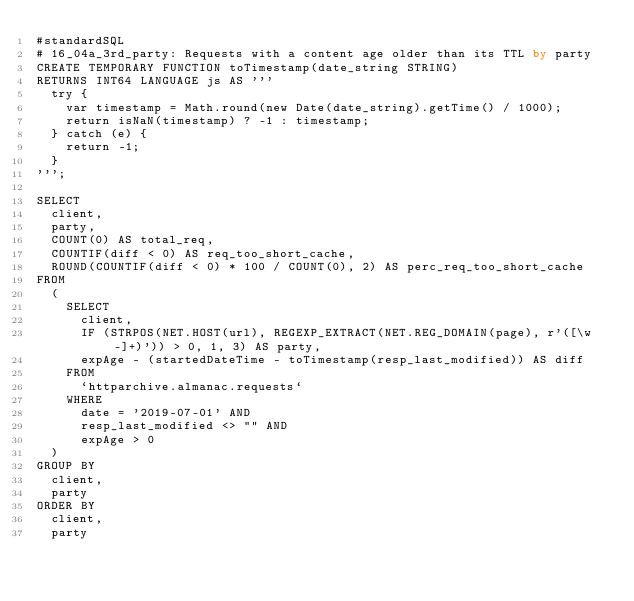<code> <loc_0><loc_0><loc_500><loc_500><_SQL_>#standardSQL
# 16_04a_3rd_party: Requests with a content age older than its TTL by party
CREATE TEMPORARY FUNCTION toTimestamp(date_string STRING)
RETURNS INT64 LANGUAGE js AS '''
  try {
    var timestamp = Math.round(new Date(date_string).getTime() / 1000);
    return isNaN(timestamp) ? -1 : timestamp;
  } catch (e) {
    return -1;
  }
''';

SELECT
  client,
  party,
  COUNT(0) AS total_req,
  COUNTIF(diff < 0) AS req_too_short_cache,
  ROUND(COUNTIF(diff < 0) * 100 / COUNT(0), 2) AS perc_req_too_short_cache
FROM
  (
    SELECT
      client,
      IF (STRPOS(NET.HOST(url), REGEXP_EXTRACT(NET.REG_DOMAIN(page), r'([\w-]+)')) > 0, 1, 3) AS party,
      expAge - (startedDateTime - toTimestamp(resp_last_modified)) AS diff
    FROM
      `httparchive.almanac.requests`
    WHERE
      date = '2019-07-01' AND
      resp_last_modified <> "" AND
      expAge > 0
  )
GROUP BY
  client,
  party
ORDER BY
  client,
  party
</code> 